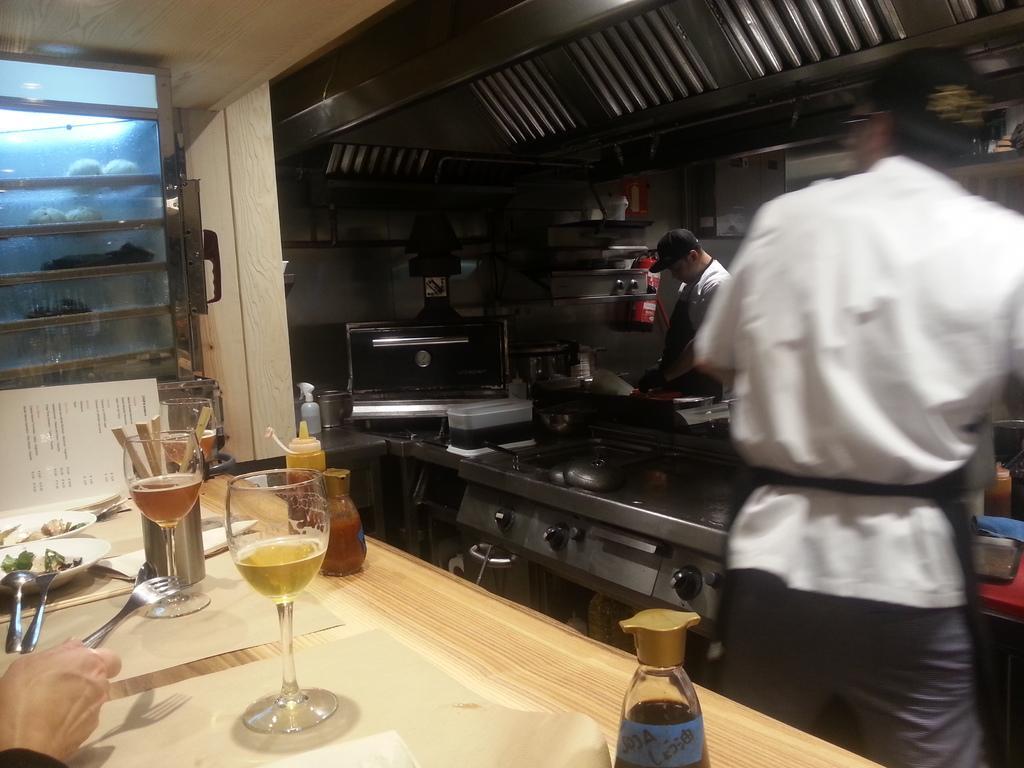Please provide a concise description of this image. In this image there is a person standing near the stove and there is fork , spoon , plate , glass , sauce bottle in the table and in the back ground there is another person , some items in the rack , and a refrigerator. 